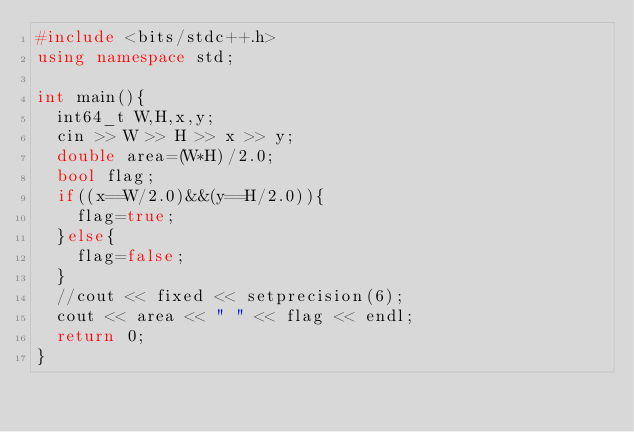<code> <loc_0><loc_0><loc_500><loc_500><_C++_>#include <bits/stdc++.h>
using namespace std;

int main(){
  int64_t W,H,x,y;
  cin >> W >> H >> x >> y;
  double area=(W*H)/2.0;
  bool flag;
  if((x==W/2.0)&&(y==H/2.0)){
    flag=true;
  }else{
    flag=false;
  }
  //cout << fixed << setprecision(6);
  cout << area << " " << flag << endl;
  return 0;
}
</code> 